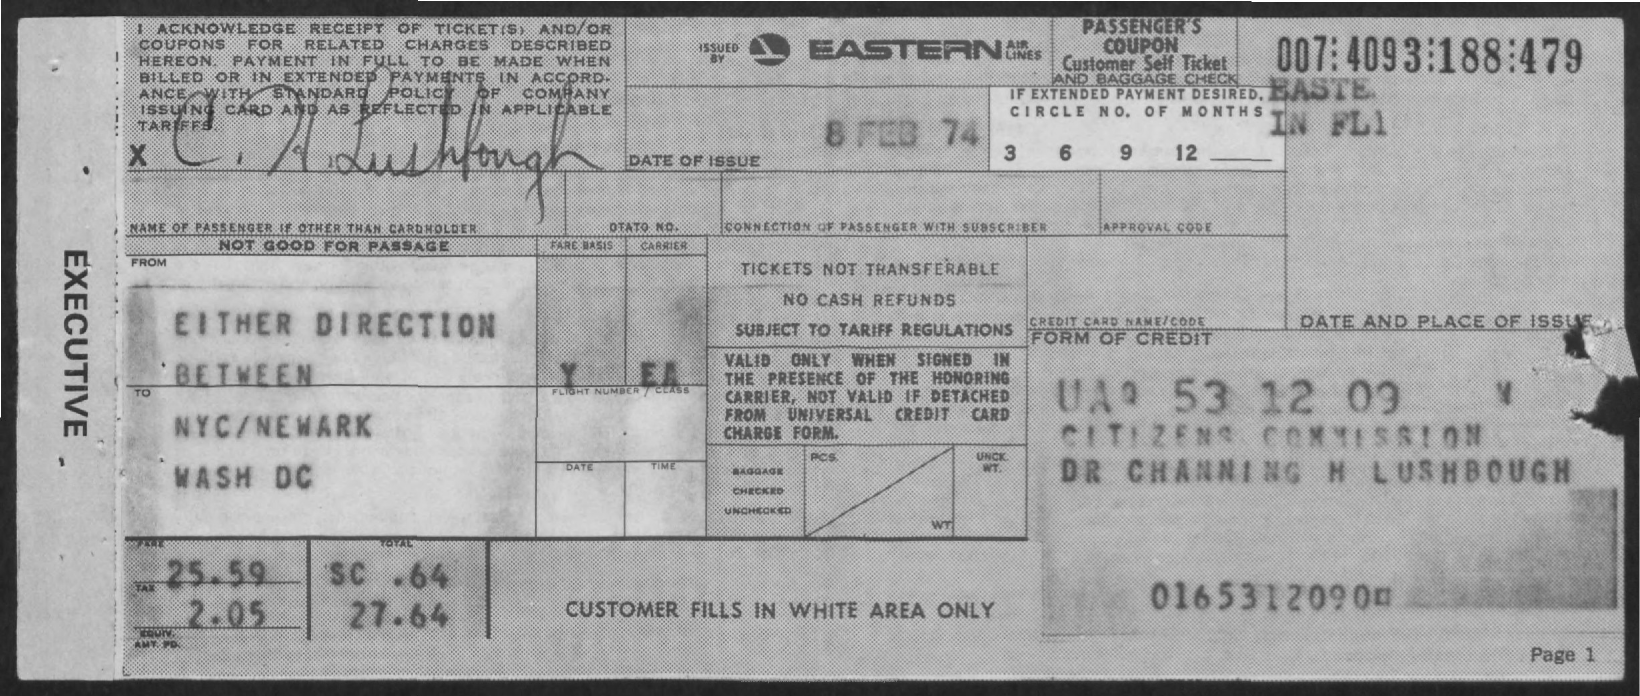What is the date of issue mentioned in the given form ?
Provide a short and direct response. 8 FEB 74. By whom this form is issued ?
Ensure brevity in your answer.  Eastern airlines. What is the amount of fare mentioned in the given form ?
Ensure brevity in your answer.  25.59. What is the amount of tax mentioned in the given form ?
Your response must be concise. 2.05. What is the total amount mentioned in the given form ?
Make the answer very short. 27.64. 